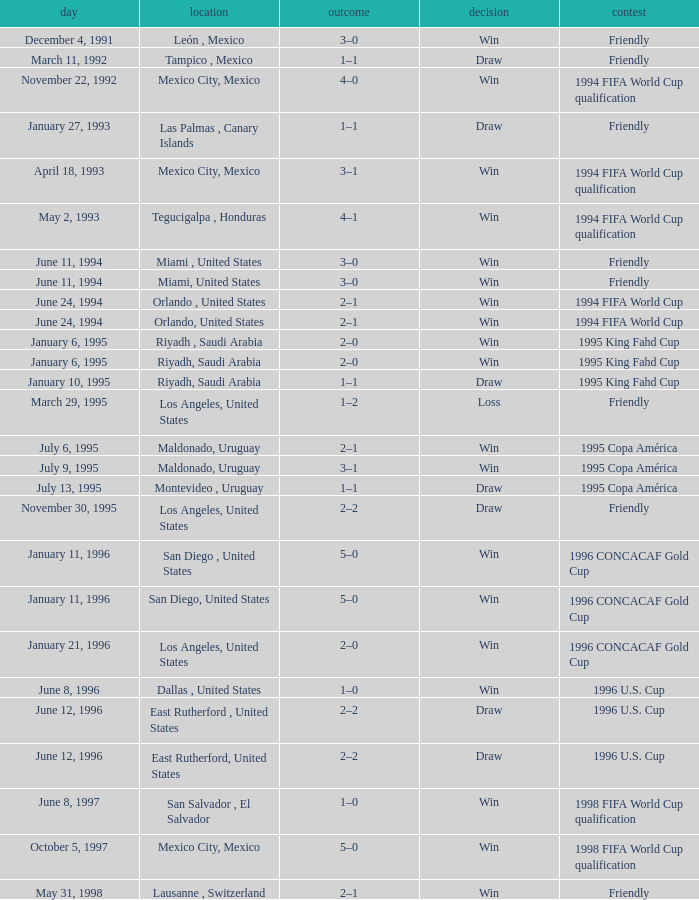What is Score, when Date is "June 8, 1996"? 1–0. 